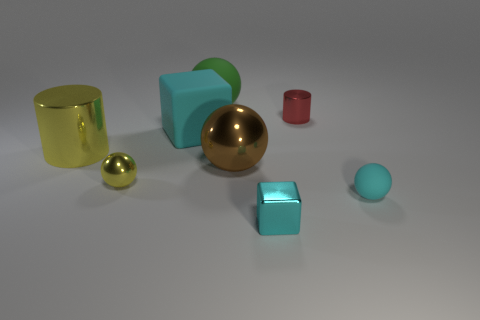Subtract all small metal spheres. How many spheres are left? 3 Add 2 small blue metal cylinders. How many objects exist? 10 Subtract all green spheres. How many spheres are left? 3 Subtract 2 cylinders. How many cylinders are left? 0 Subtract all cubes. How many objects are left? 6 Subtract all cyan balls. Subtract all tiny cyan metal spheres. How many objects are left? 7 Add 7 large green rubber objects. How many large green rubber objects are left? 8 Add 8 tiny shiny spheres. How many tiny shiny spheres exist? 9 Subtract 0 gray cubes. How many objects are left? 8 Subtract all red balls. Subtract all cyan blocks. How many balls are left? 4 